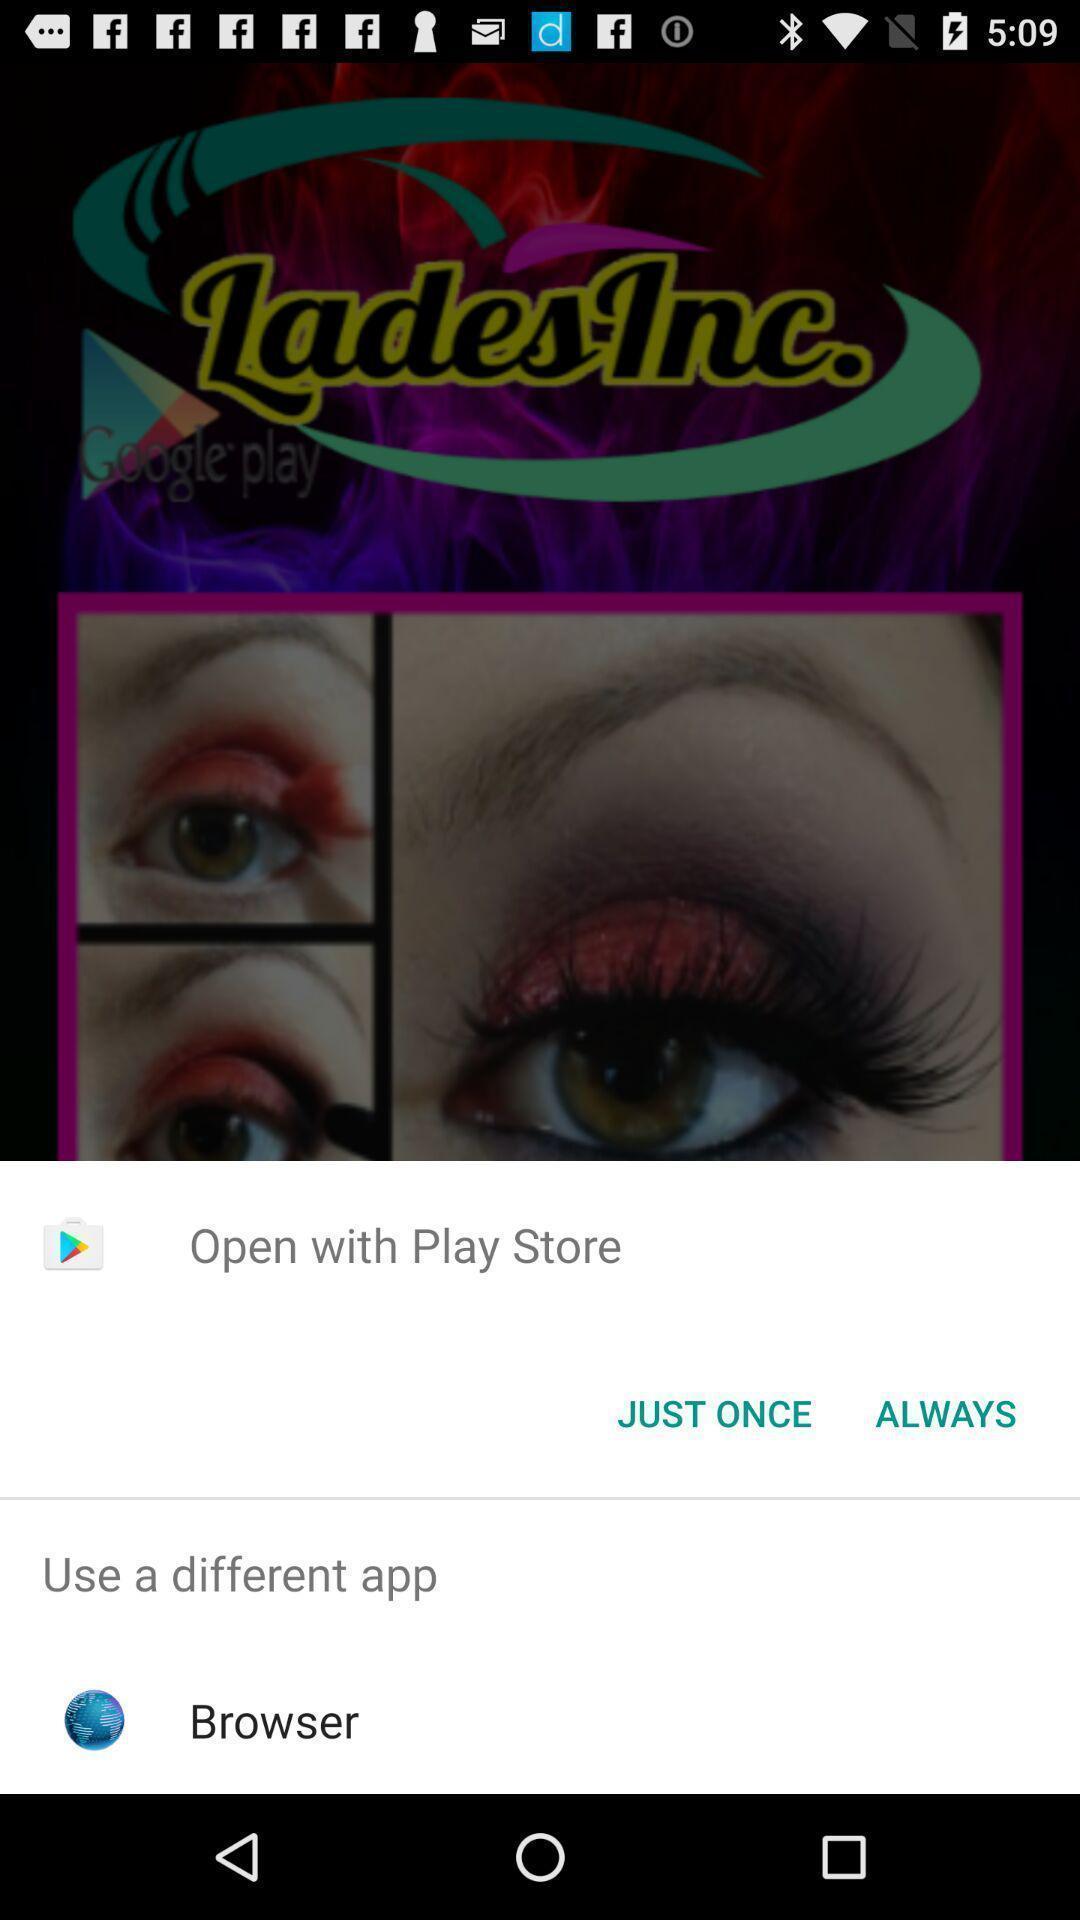Give me a summary of this screen capture. Pop-up widget showing browsing options. 